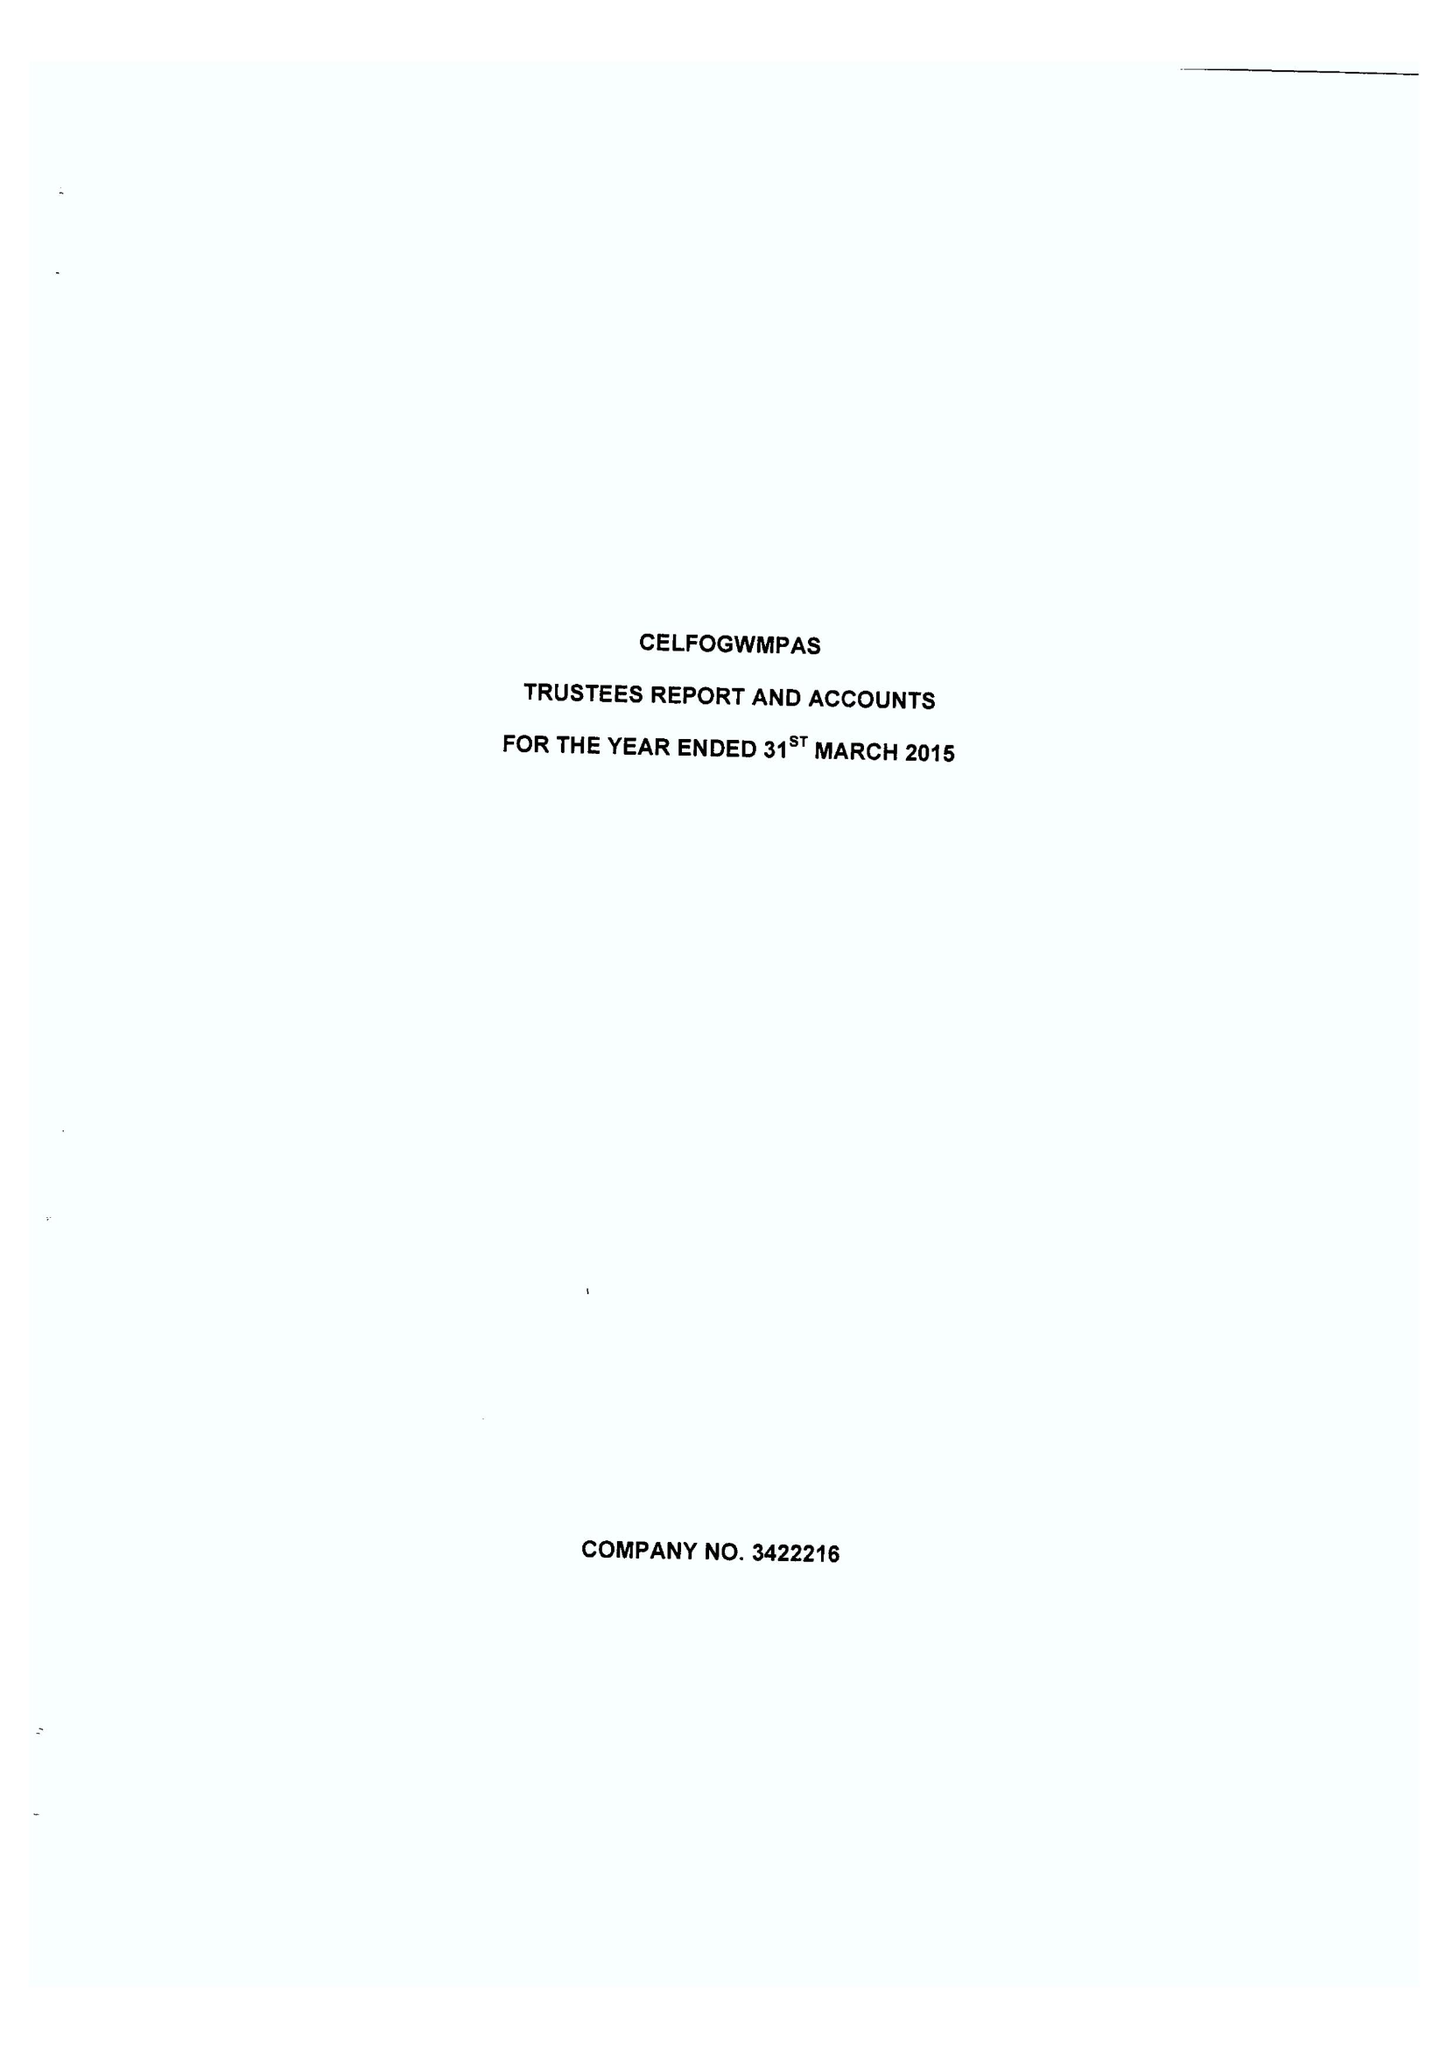What is the value for the address__post_town?
Answer the question using a single word or phrase. LLANDRINDOD WELLS 